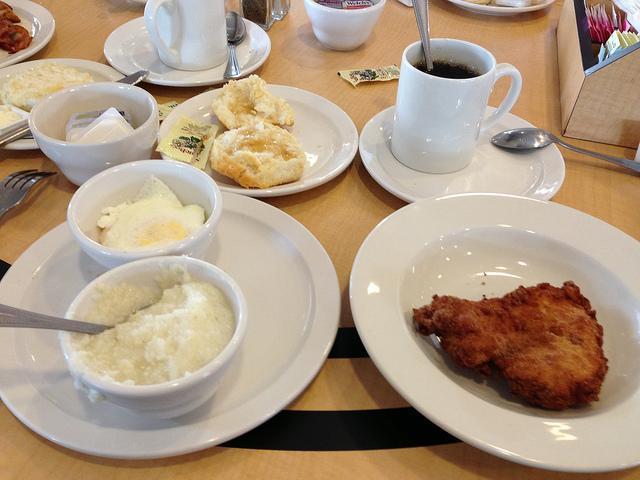How many cups are in the picture?
Give a very brief answer. 2. How many bowls can you see?
Give a very brief answer. 5. 